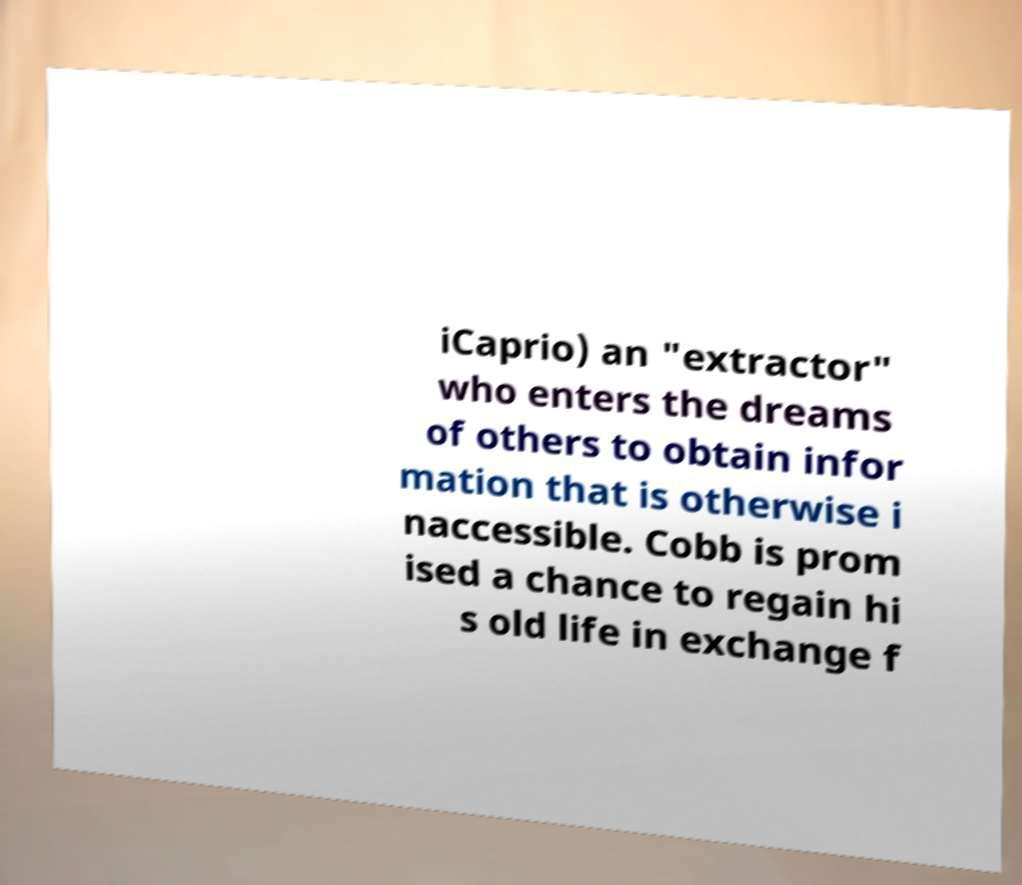Please identify and transcribe the text found in this image. iCaprio) an "extractor" who enters the dreams of others to obtain infor mation that is otherwise i naccessible. Cobb is prom ised a chance to regain hi s old life in exchange f 